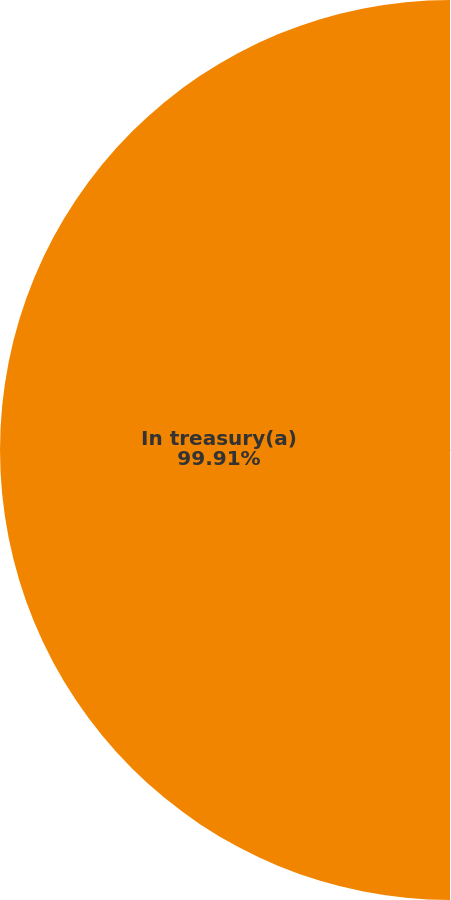Convert chart. <chart><loc_0><loc_0><loc_500><loc_500><pie_chart><fcel>December 31 (In thousands)<fcel>In treasury(a)<nl><fcel>0.09%<fcel>99.91%<nl></chart> 